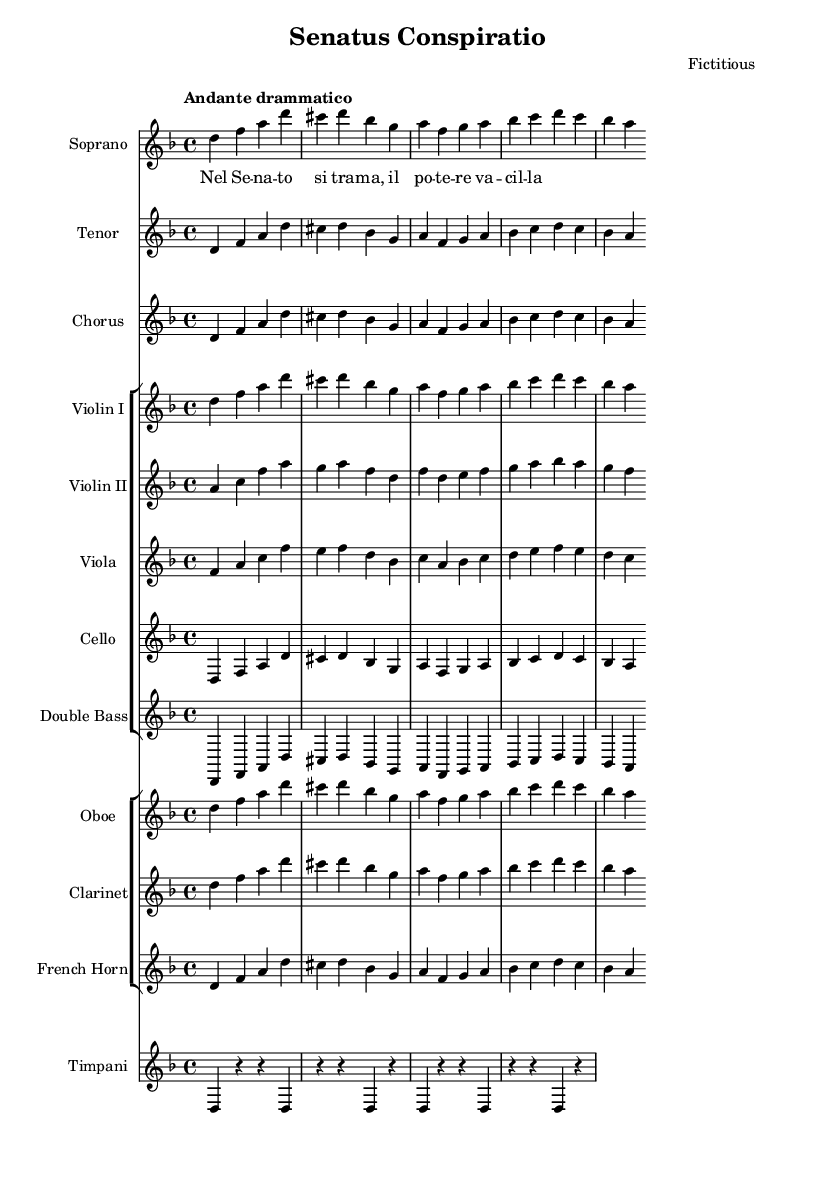What is the key signature of this music? The key signature is indicated at the beginning of the staff. There is one flat, which represents B flat. This key signature corresponds to D minor.
Answer: D minor What is the time signature of the music? The time signature is found at the beginning of the score. It shows 4 over 4, meaning there are four beats in each measure and a quarter note receives one beat.
Answer: 4/4 What is the tempo marking of the piece? The tempo marking appears near the beginning of the score, stating "Andante drammatico," which indicates a moderately slow and dramatic pace for the music.
Answer: Andante drammatico How many voices are present in this composition? By examining the score, we can see distinct staves labeled for Soprano, Tenor, and Chorus, indicating three unique voices are present in this composition.
Answer: Three What is the primary theme presented in the soprano lyrics? The lyrics provided are “Nel Senato si trama, il potere vacilla.” This translates to themes of conspiracy and power struggles in the Roman Senate, central to the opera.
Answer: Conspiracy and power struggles Which instrument plays the timpani? The score labels a separate staff for Timpani, indicating that this instrument plays a significant role, particularly in dramatic sections.
Answer: Timpani What type of composition is represented in this music sheet? Given the structure, instrumentation, and themes of the lyrics, this composition is classified as an opera, highlighting themes of political intrigue and power struggles.
Answer: Opera 